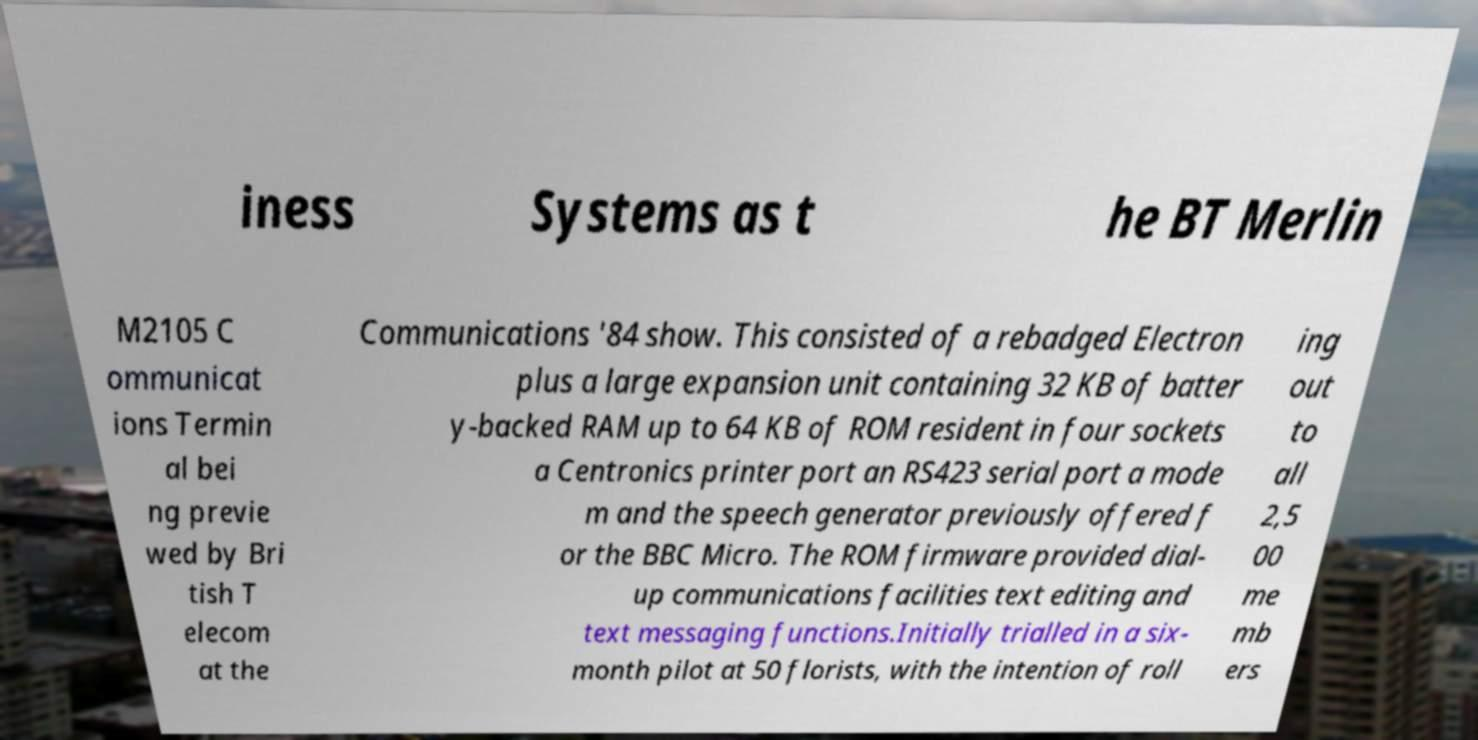Can you read and provide the text displayed in the image?This photo seems to have some interesting text. Can you extract and type it out for me? iness Systems as t he BT Merlin M2105 C ommunicat ions Termin al bei ng previe wed by Bri tish T elecom at the Communications '84 show. This consisted of a rebadged Electron plus a large expansion unit containing 32 KB of batter y-backed RAM up to 64 KB of ROM resident in four sockets a Centronics printer port an RS423 serial port a mode m and the speech generator previously offered f or the BBC Micro. The ROM firmware provided dial- up communications facilities text editing and text messaging functions.Initially trialled in a six- month pilot at 50 florists, with the intention of roll ing out to all 2,5 00 me mb ers 